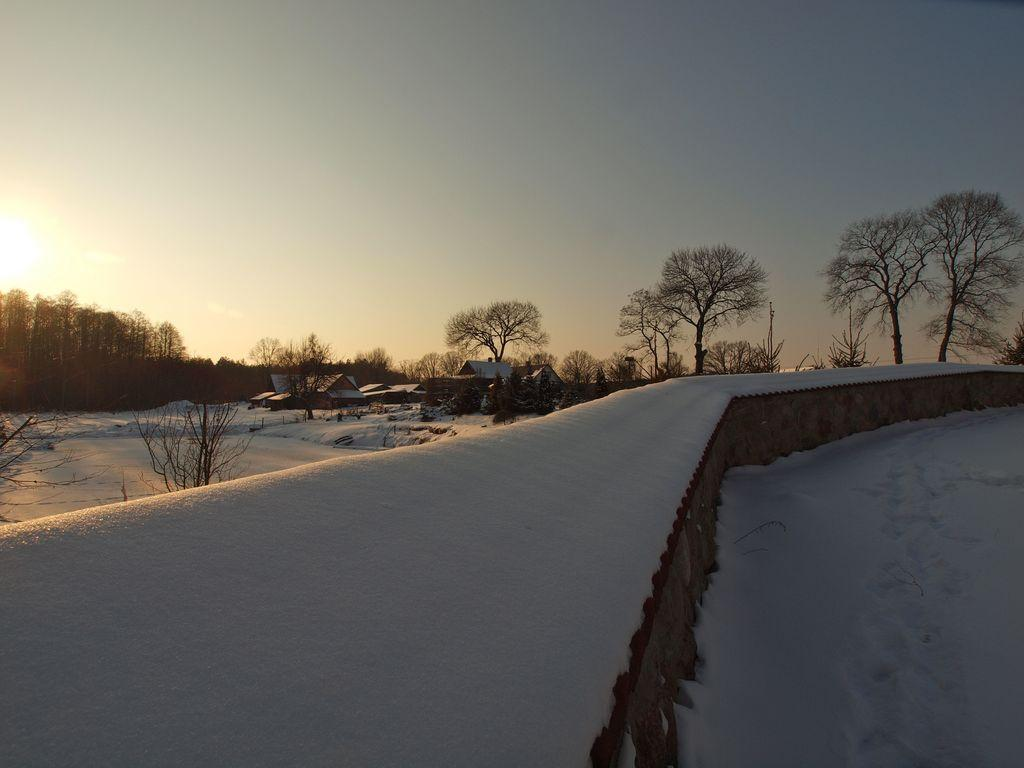What is covering the wall in the image? The wall is covered with snow. What can be seen in the background of the image? There is a group of houses with roofs and a group of trees in the background. What is visible in the sky in the image? The sun is visible in the background, and the sky appears cloudy. Can you see any deer running through the snow in the image? There are no deer present in the image; it only features a snow-covered wall and elements in the background. 